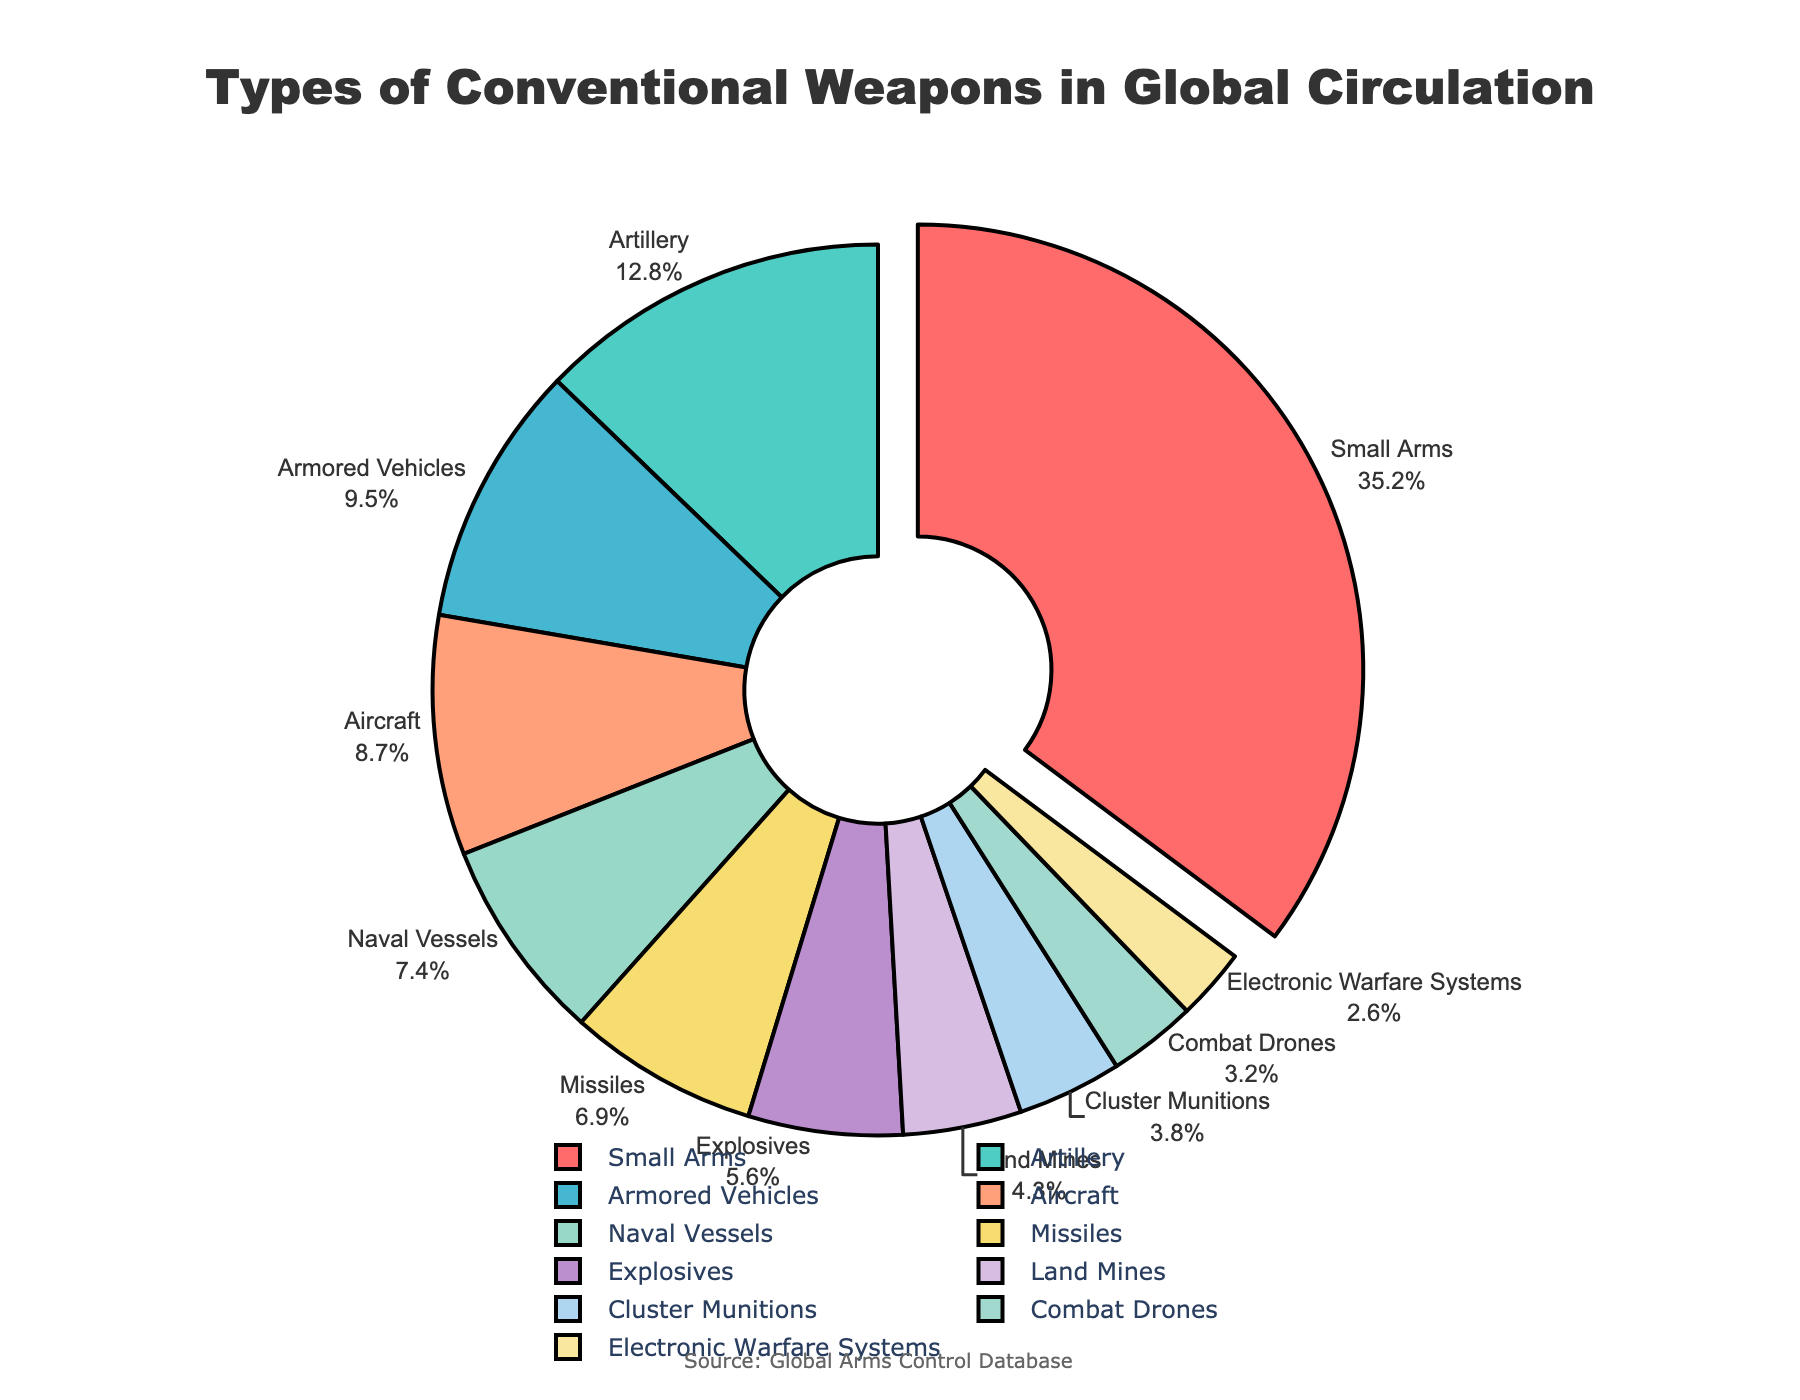What percentage of the total types of conventional weapons in global circulation is accounted for by Small Arms and Artillery combined? First, identify the individual percentages from the chart: Small Arms (35.2%) and Artillery (12.8%). Then, add these two percentages together: 35.2 + 12.8 = 48.0
Answer: 48.0 Is the percentage of Armored Vehicles higher than that of Naval Vessels? Look at the chart to find the percentages of Armored Vehicles and Naval Vessels: Armored Vehicles (9.5%) and Naval Vessels (7.4%). Compare these two numbers to see which is higher.
Answer: Yes Which category has the smallest percentage of conventional weapons in global circulation? Examine the chart for the smallest percentage value. The category with the smallest value is Combat Drones at 3.2%.
Answer: Combat Drones What is the difference in percentage between Small Arms and Explosives? Identify the values for Small Arms (35.2%) and Explosives (5.6%) from the chart. Subtract the percentage of Explosives from Small Arms: 35.2 - 5.6 = 29.6
Answer: 29.6 Is the percentage of Missiles more than half the percentage of Small Arms? First, identify the percentages of Missiles (6.9%) and Small Arms (35.2%). Calculate half of Small Arms: 35.2 / 2 = 17.6. Compare this with the percentage of Missiles to determine if it is more.
Answer: No What is the combined percentage of Land Mines, Cluster Munitions, and Combat Drones? Identify each of the percentages from the chart: Land Mines (4.3%), Cluster Munitions (3.8%), and Combat Drones (3.2%). Add these percentages together: 4.3 + 3.8 + 3.2 = 11.3
Answer: 11.3 Which category is represented with a 0.1 pull effect in the pie chart? According to the description, a 0.1 pull effect is used on the category with the highest percentage, which is Small Arms at 35.2%.
Answer: Small Arms How many categories have a percentage greater than 10%? Observe the chart and count the categories with percentages higher than 10%. These are Small Arms (35.2%) and Artillery (12.8%), totaling 2 categories.
Answer: 2 